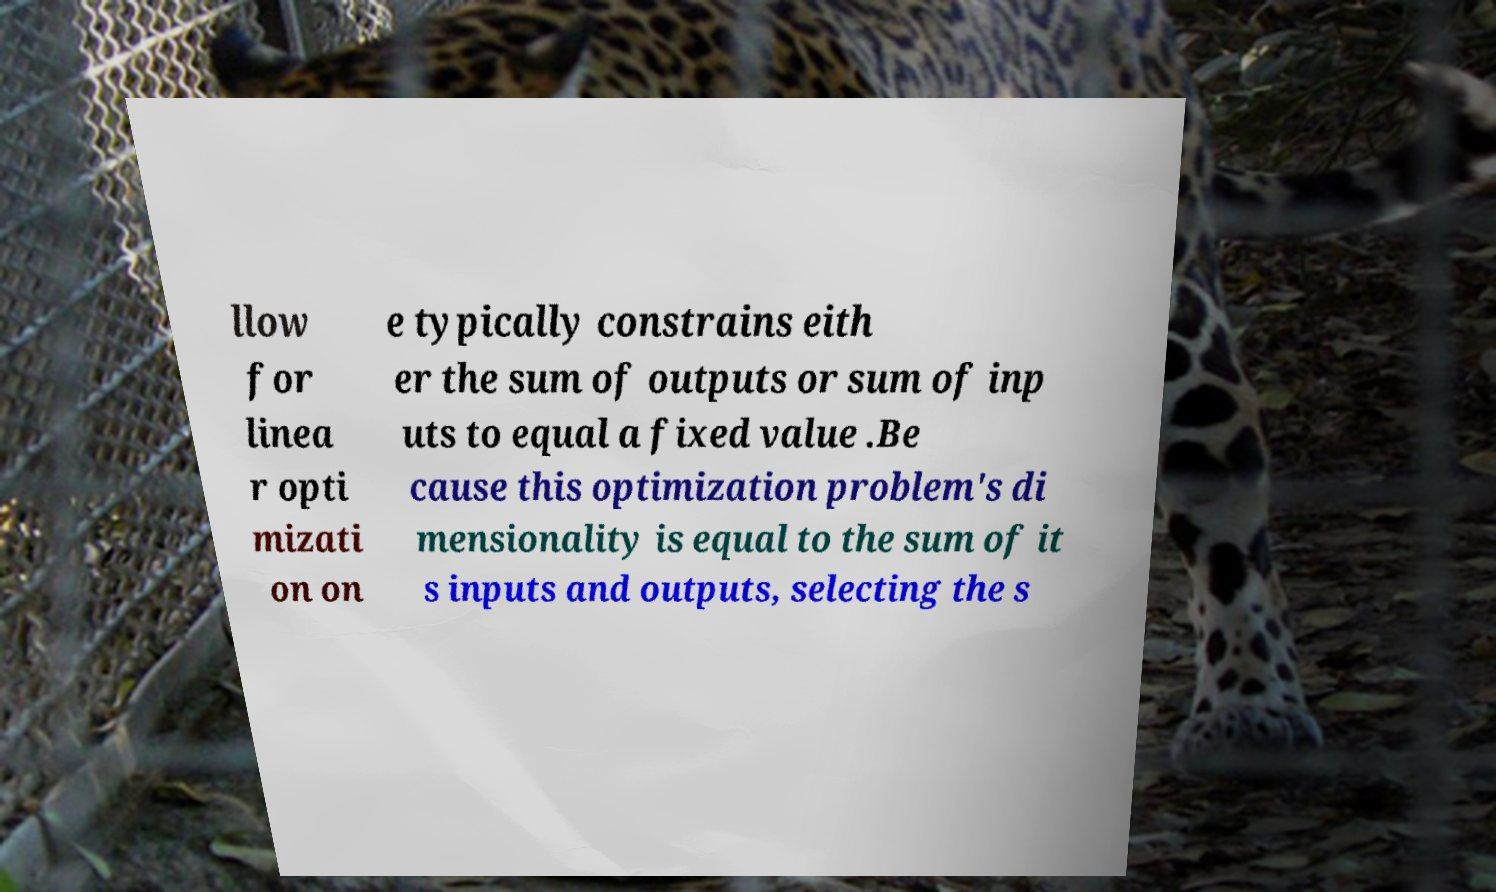For documentation purposes, I need the text within this image transcribed. Could you provide that? llow for linea r opti mizati on on e typically constrains eith er the sum of outputs or sum of inp uts to equal a fixed value .Be cause this optimization problem's di mensionality is equal to the sum of it s inputs and outputs, selecting the s 